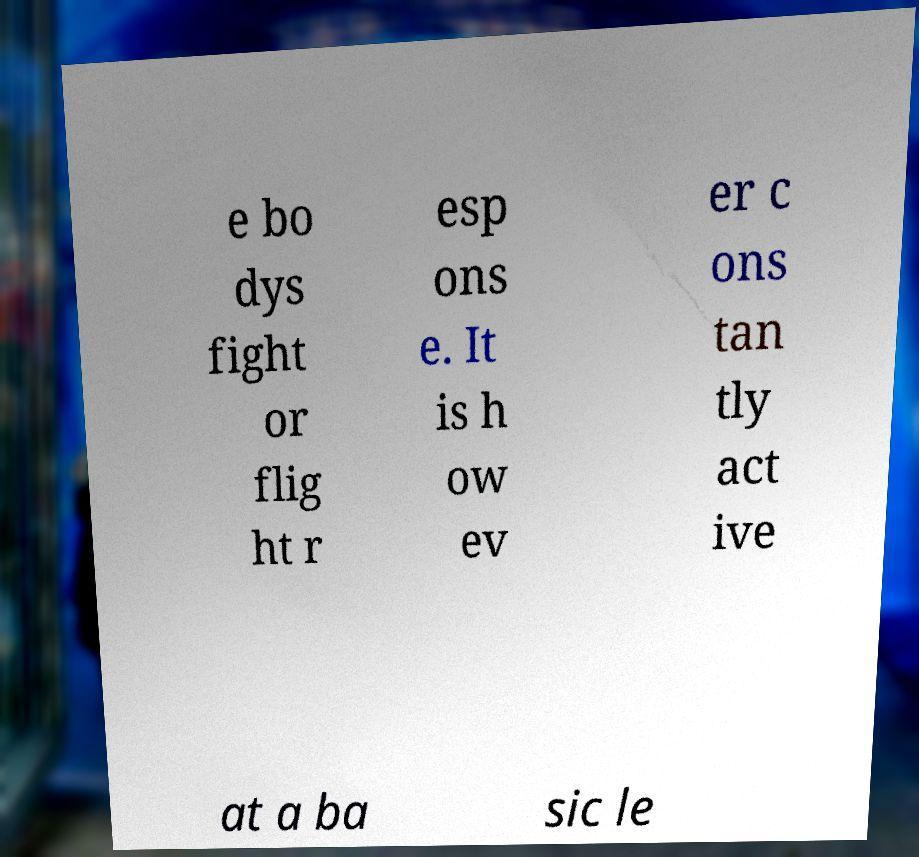For documentation purposes, I need the text within this image transcribed. Could you provide that? e bo dys fight or flig ht r esp ons e. It is h ow ev er c ons tan tly act ive at a ba sic le 